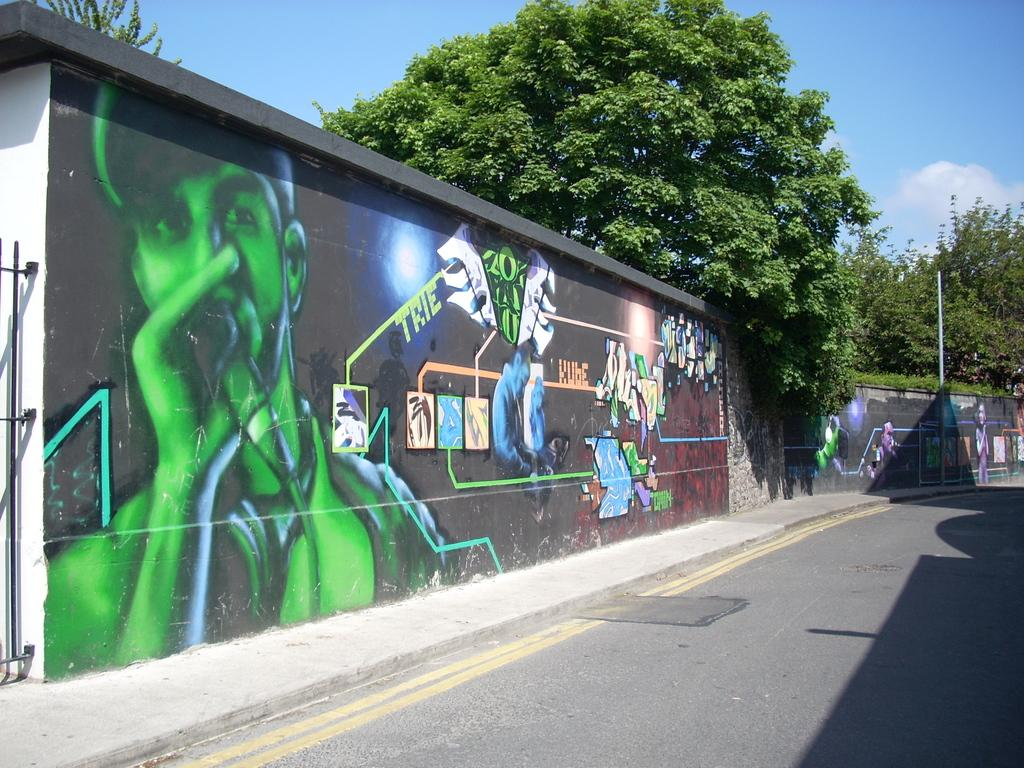What is depicted on the wall in the image? There is graffiti on a wall in the image. What type of natural elements can be seen in the image? There are trees visible in the image. What color is the sky in the image? The sky is blue in the image. Can you tell me how many apples are growing on the trees in the image? There are no apples present in the image; only trees are visible. What is the rate at which the graffiti is being created in the image? The image is a still photograph, so it does not show the process of creating the graffiti or any rate at which it is being created. 